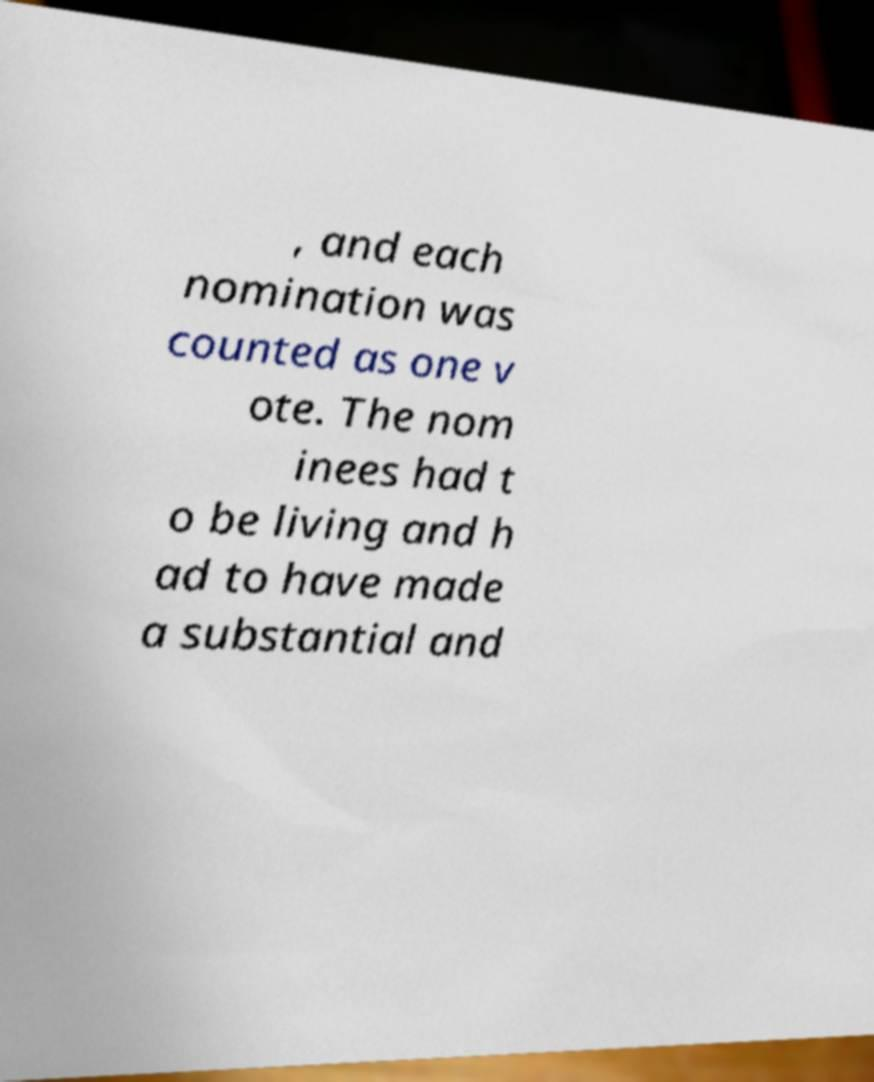Please identify and transcribe the text found in this image. , and each nomination was counted as one v ote. The nom inees had t o be living and h ad to have made a substantial and 